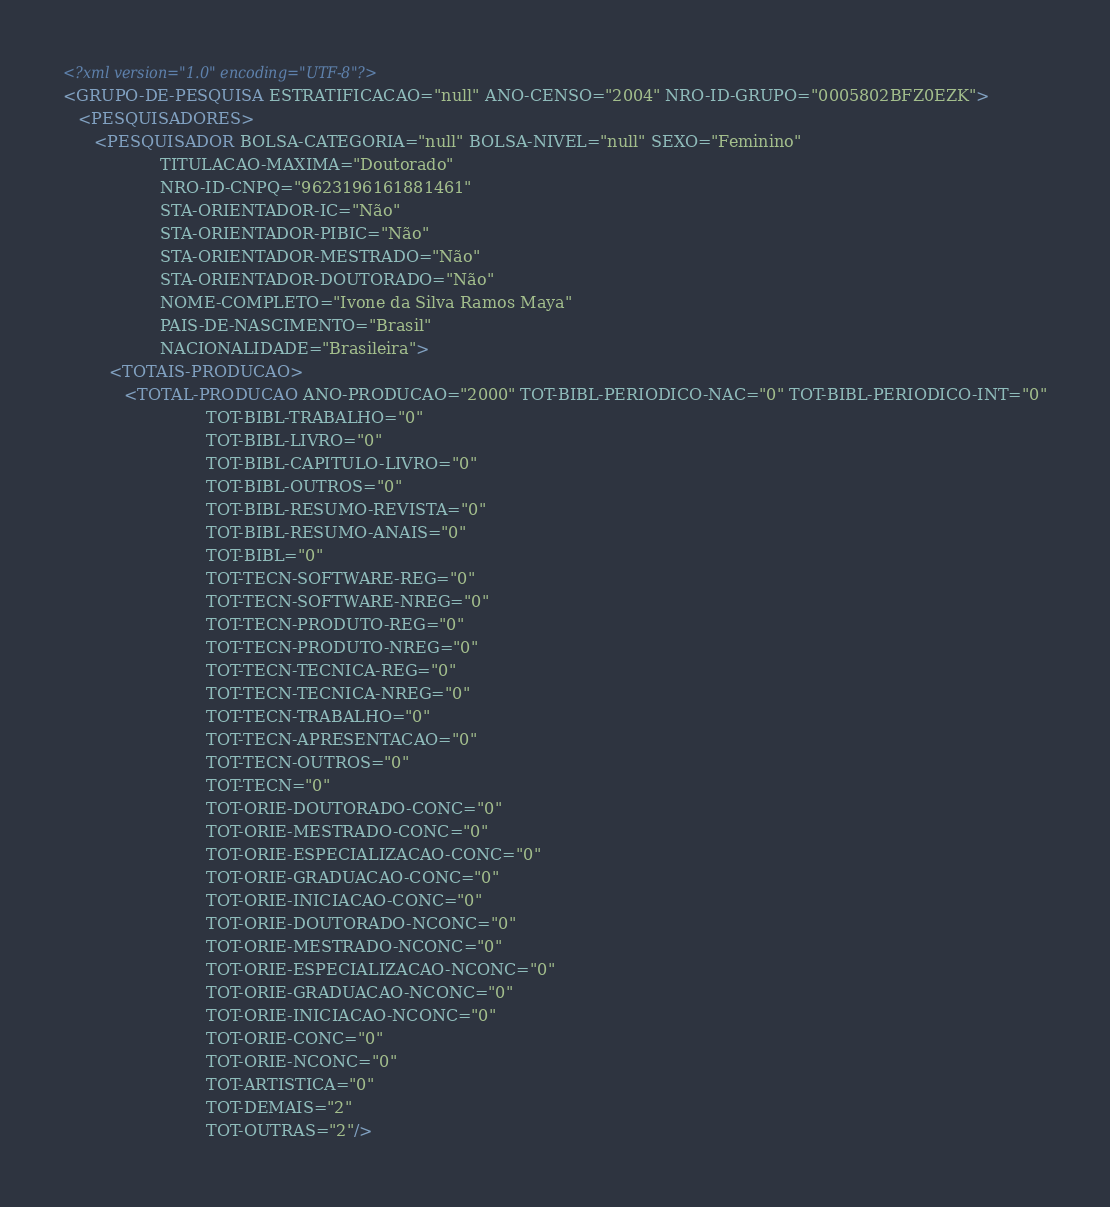<code> <loc_0><loc_0><loc_500><loc_500><_XML_><?xml version="1.0" encoding="UTF-8"?>
<GRUPO-DE-PESQUISA ESTRATIFICACAO="null" ANO-CENSO="2004" NRO-ID-GRUPO="0005802BFZ0EZK">
   <PESQUISADORES>
      <PESQUISADOR BOLSA-CATEGORIA="null" BOLSA-NIVEL="null" SEXO="Feminino"
                   TITULACAO-MAXIMA="Doutorado"
                   NRO-ID-CNPQ="9623196161881461"
                   STA-ORIENTADOR-IC="Não"
                   STA-ORIENTADOR-PIBIC="Não"
                   STA-ORIENTADOR-MESTRADO="Não"
                   STA-ORIENTADOR-DOUTORADO="Não"
                   NOME-COMPLETO="Ivone da Silva Ramos Maya"
                   PAIS-DE-NASCIMENTO="Brasil"
                   NACIONALIDADE="Brasileira">
         <TOTAIS-PRODUCAO>
            <TOTAL-PRODUCAO ANO-PRODUCAO="2000" TOT-BIBL-PERIODICO-NAC="0" TOT-BIBL-PERIODICO-INT="0"
                            TOT-BIBL-TRABALHO="0"
                            TOT-BIBL-LIVRO="0"
                            TOT-BIBL-CAPITULO-LIVRO="0"
                            TOT-BIBL-OUTROS="0"
                            TOT-BIBL-RESUMO-REVISTA="0"
                            TOT-BIBL-RESUMO-ANAIS="0"
                            TOT-BIBL="0"
                            TOT-TECN-SOFTWARE-REG="0"
                            TOT-TECN-SOFTWARE-NREG="0"
                            TOT-TECN-PRODUTO-REG="0"
                            TOT-TECN-PRODUTO-NREG="0"
                            TOT-TECN-TECNICA-REG="0"
                            TOT-TECN-TECNICA-NREG="0"
                            TOT-TECN-TRABALHO="0"
                            TOT-TECN-APRESENTACAO="0"
                            TOT-TECN-OUTROS="0"
                            TOT-TECN="0"
                            TOT-ORIE-DOUTORADO-CONC="0"
                            TOT-ORIE-MESTRADO-CONC="0"
                            TOT-ORIE-ESPECIALIZACAO-CONC="0"
                            TOT-ORIE-GRADUACAO-CONC="0"
                            TOT-ORIE-INICIACAO-CONC="0"
                            TOT-ORIE-DOUTORADO-NCONC="0"
                            TOT-ORIE-MESTRADO-NCONC="0"
                            TOT-ORIE-ESPECIALIZACAO-NCONC="0"
                            TOT-ORIE-GRADUACAO-NCONC="0"
                            TOT-ORIE-INICIACAO-NCONC="0"
                            TOT-ORIE-CONC="0"
                            TOT-ORIE-NCONC="0"
                            TOT-ARTISTICA="0"
                            TOT-DEMAIS="2"
                            TOT-OUTRAS="2"/></code> 